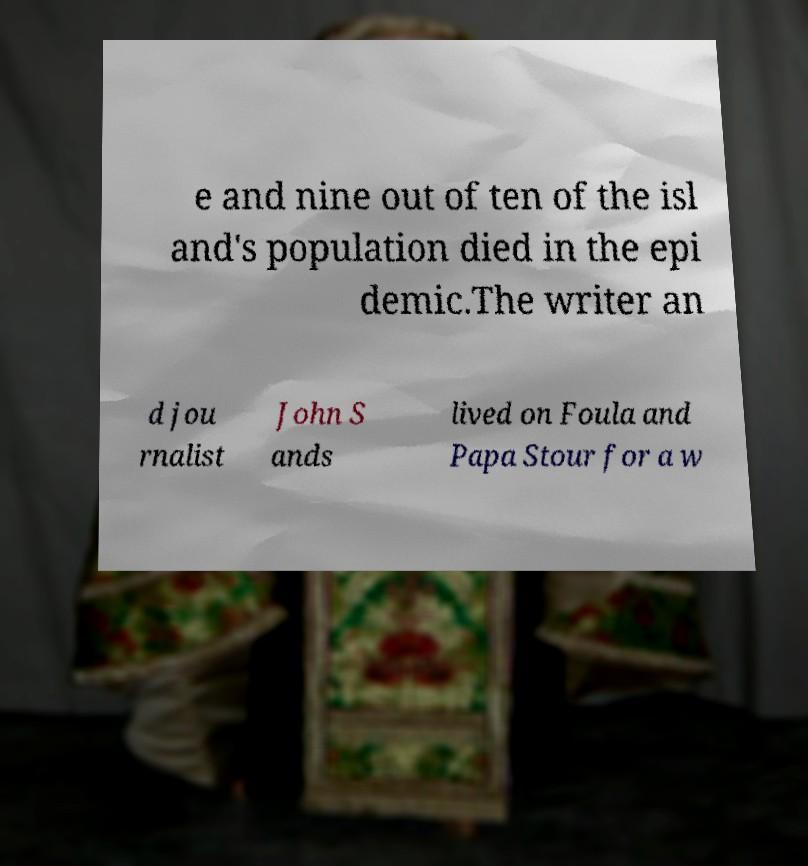I need the written content from this picture converted into text. Can you do that? e and nine out of ten of the isl and's population died in the epi demic.The writer an d jou rnalist John S ands lived on Foula and Papa Stour for a w 